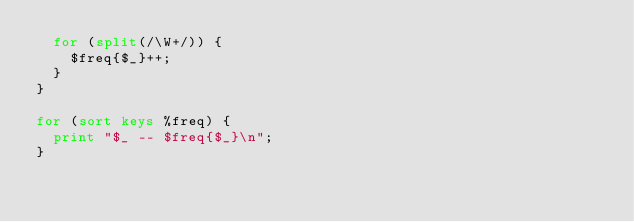<code> <loc_0><loc_0><loc_500><loc_500><_Perl_>  for (split(/\W+/)) {
    $freq{$_}++;
  }
}

for (sort keys %freq) {
  print "$_ -- $freq{$_}\n";
}
</code> 